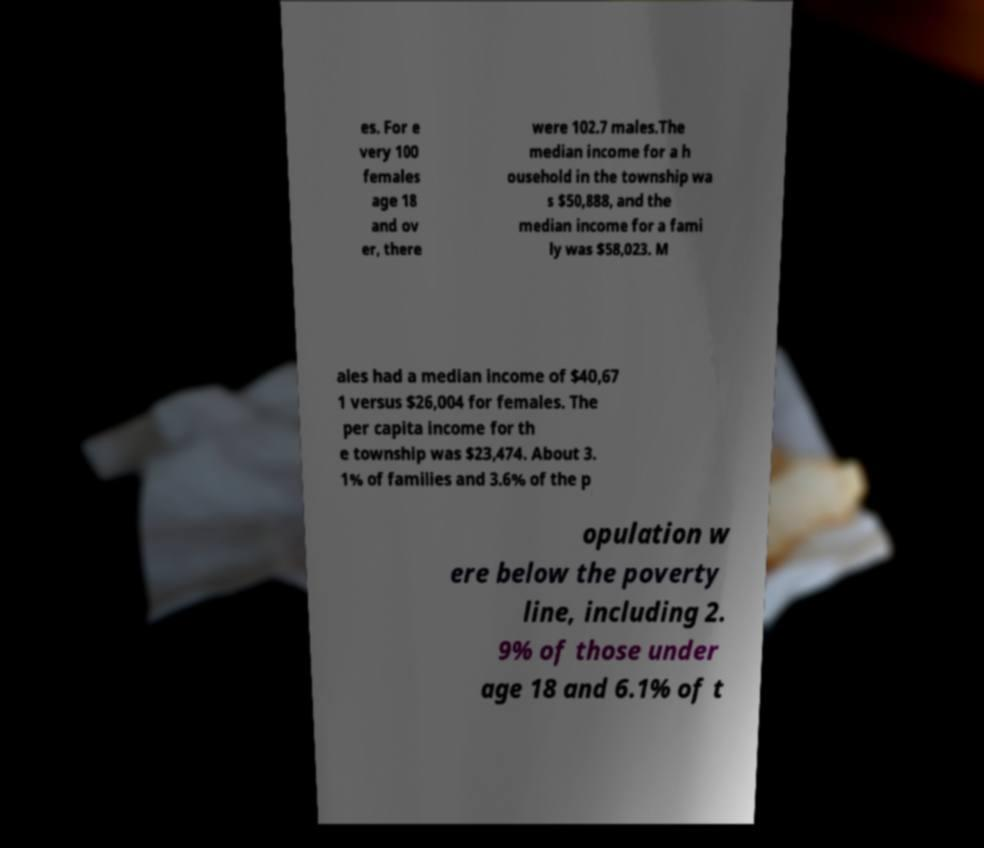Please read and relay the text visible in this image. What does it say? es. For e very 100 females age 18 and ov er, there were 102.7 males.The median income for a h ousehold in the township wa s $50,888, and the median income for a fami ly was $58,023. M ales had a median income of $40,67 1 versus $26,004 for females. The per capita income for th e township was $23,474. About 3. 1% of families and 3.6% of the p opulation w ere below the poverty line, including 2. 9% of those under age 18 and 6.1% of t 